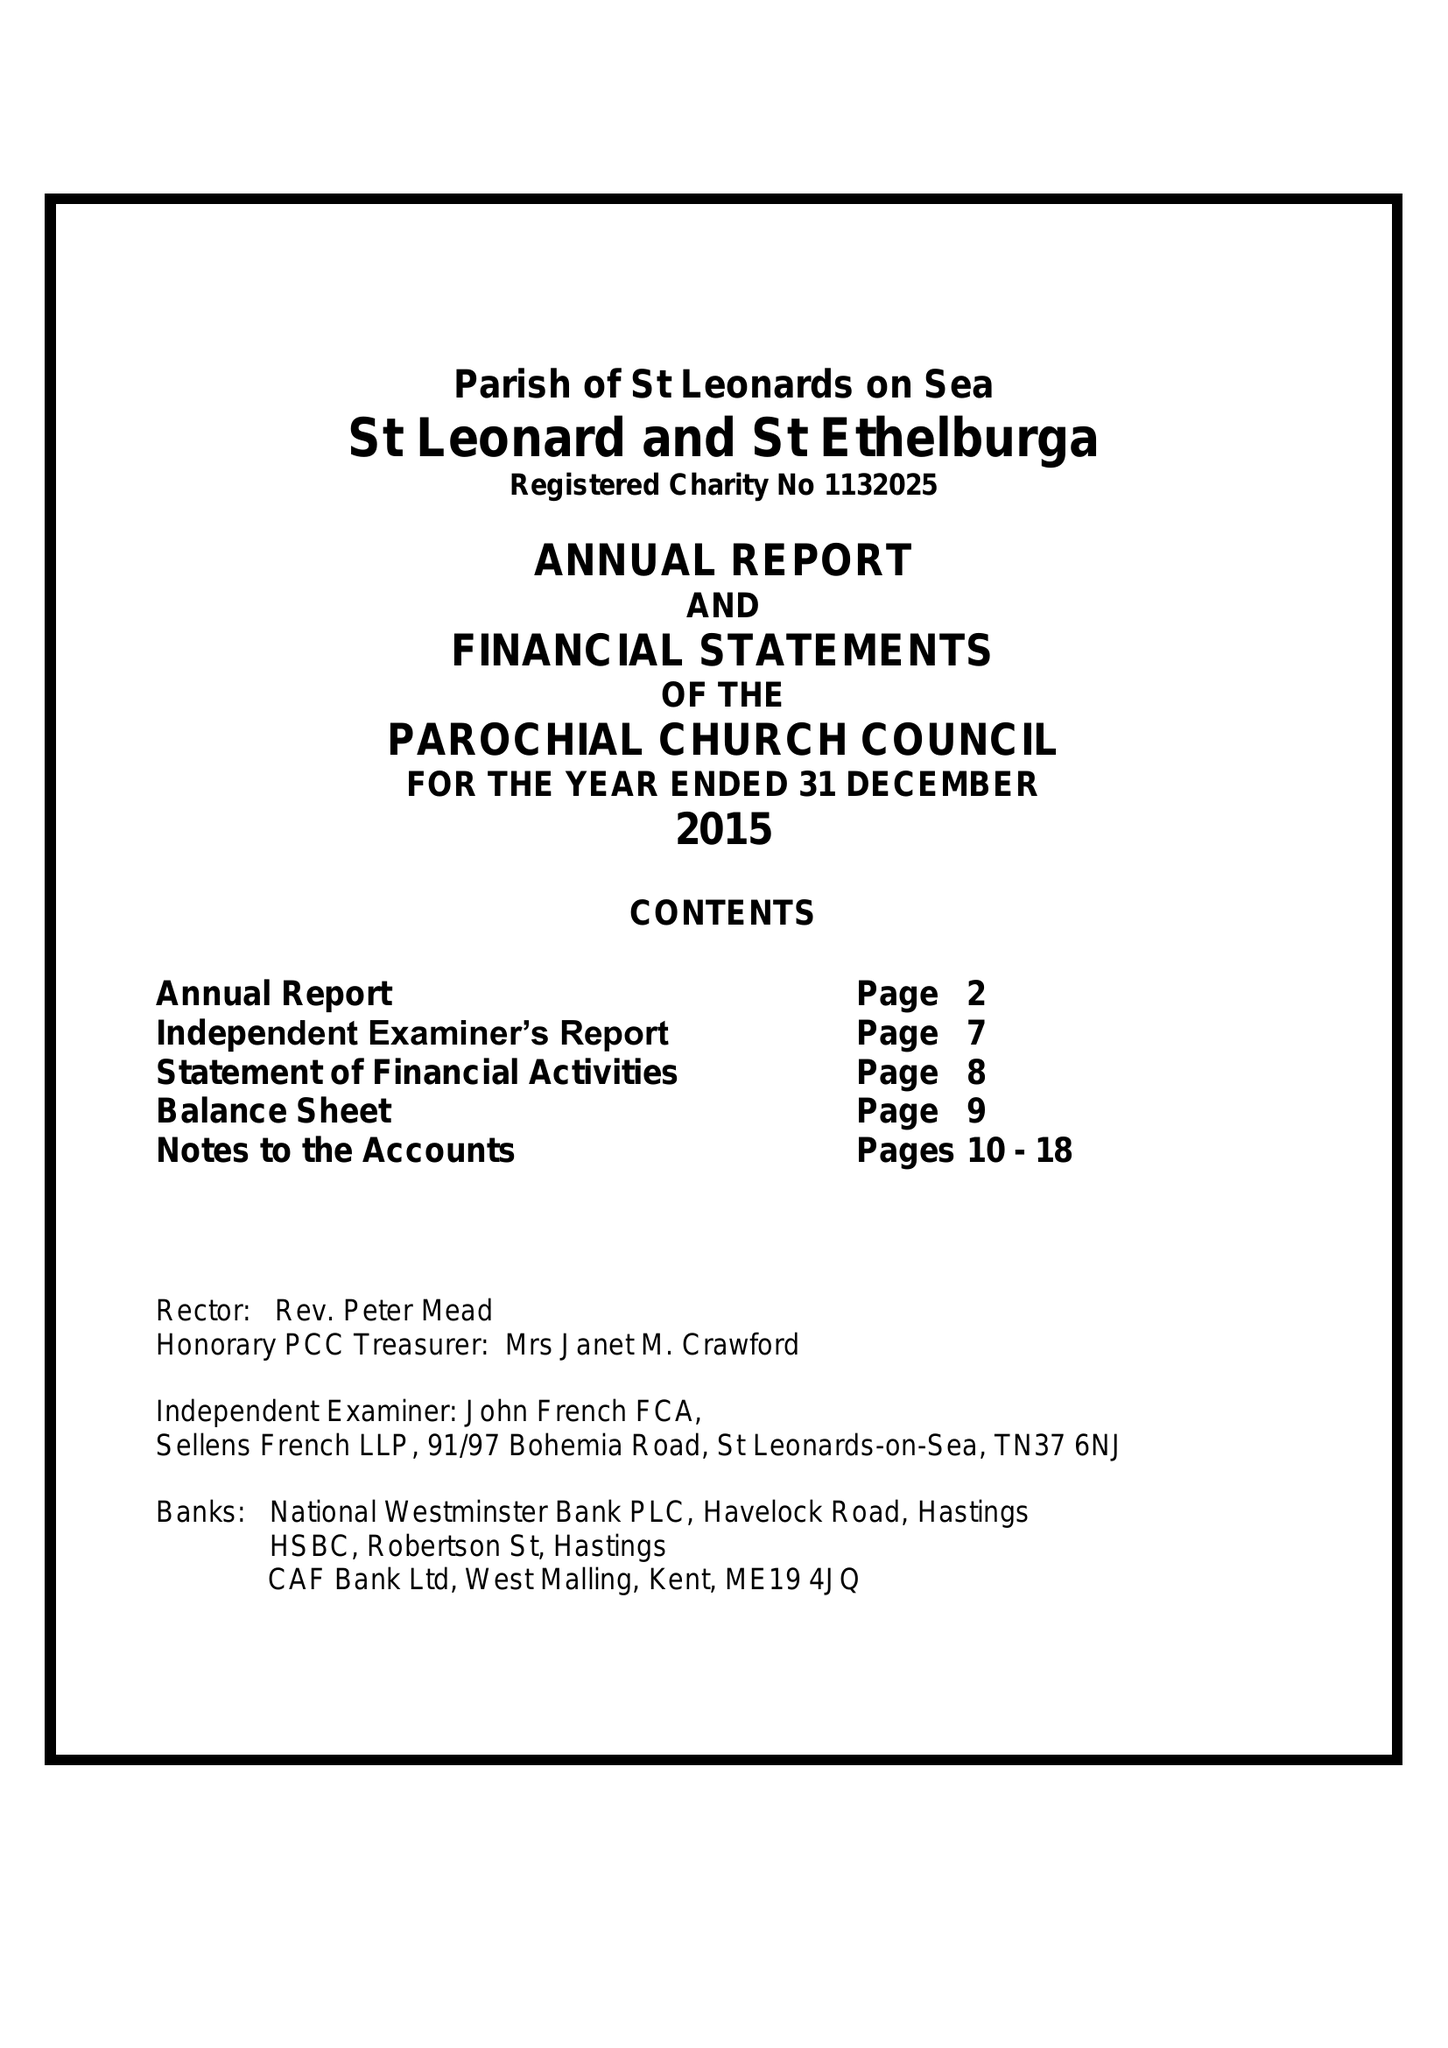What is the value for the report_date?
Answer the question using a single word or phrase. 2015-12-31 